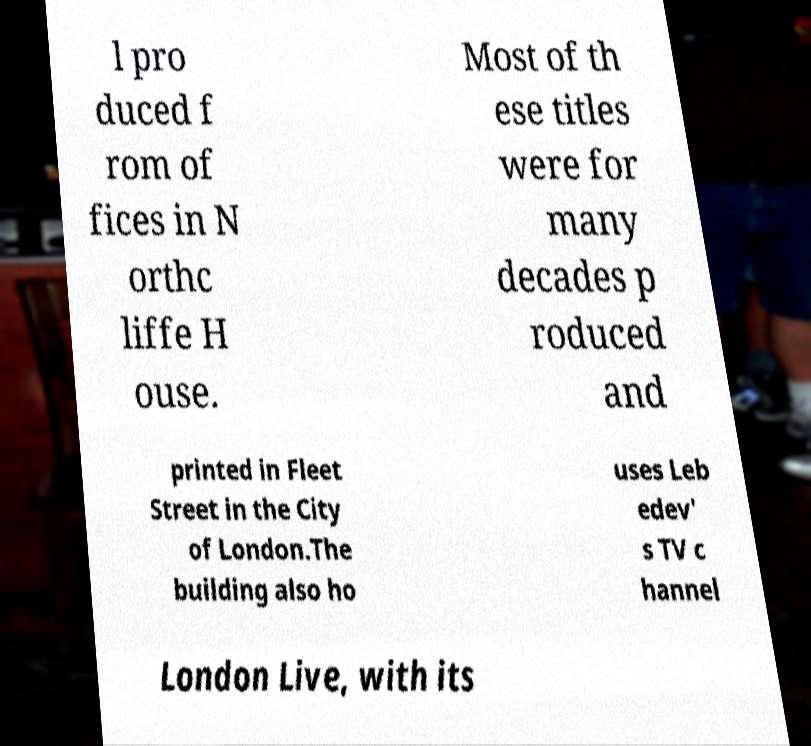There's text embedded in this image that I need extracted. Can you transcribe it verbatim? l pro duced f rom of fices in N orthc liffe H ouse. Most of th ese titles were for many decades p roduced and printed in Fleet Street in the City of London.The building also ho uses Leb edev' s TV c hannel London Live, with its 